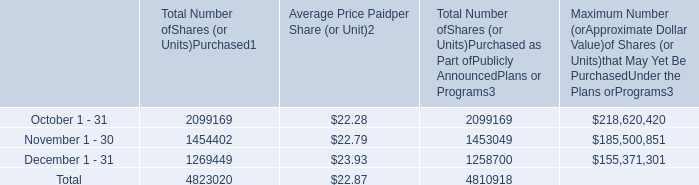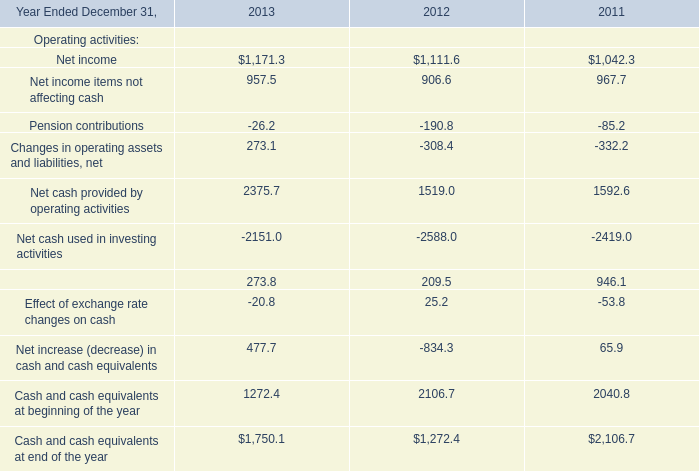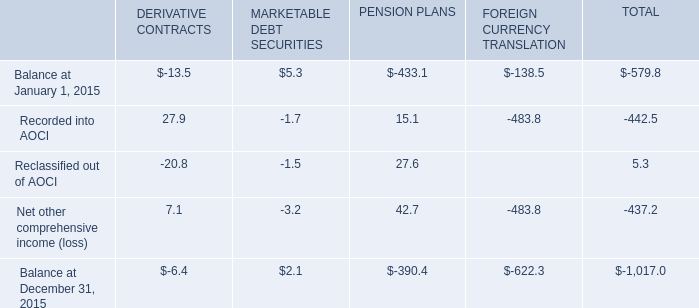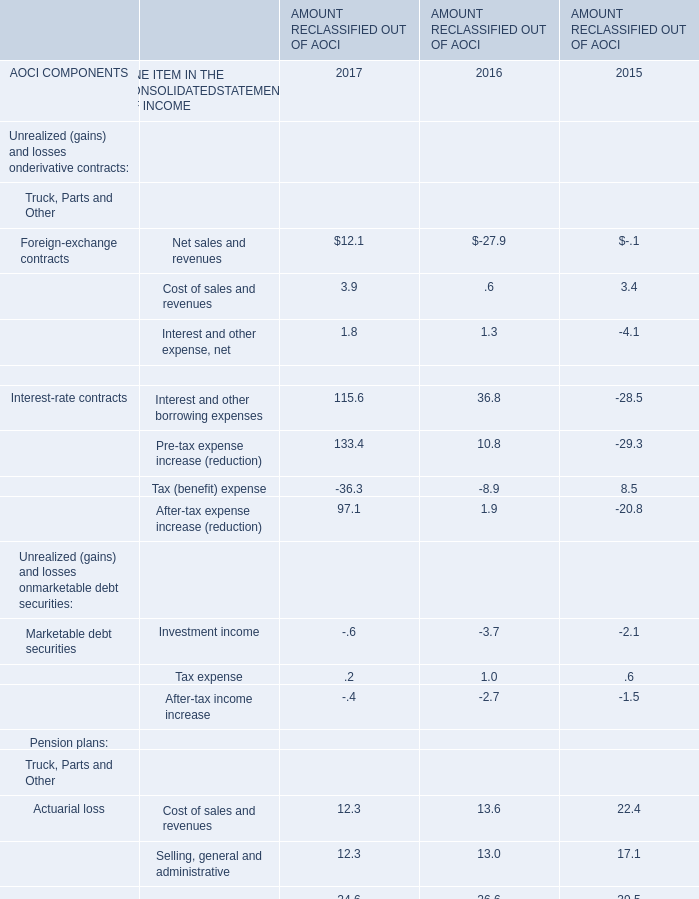What is the sum of the Net other comprehensive income (loss) in the years where Reclassified out of AOCI greater than 0? 
Computations: (((7.1 - 3.2) + 42.7) - 483.8)
Answer: -437.2. 